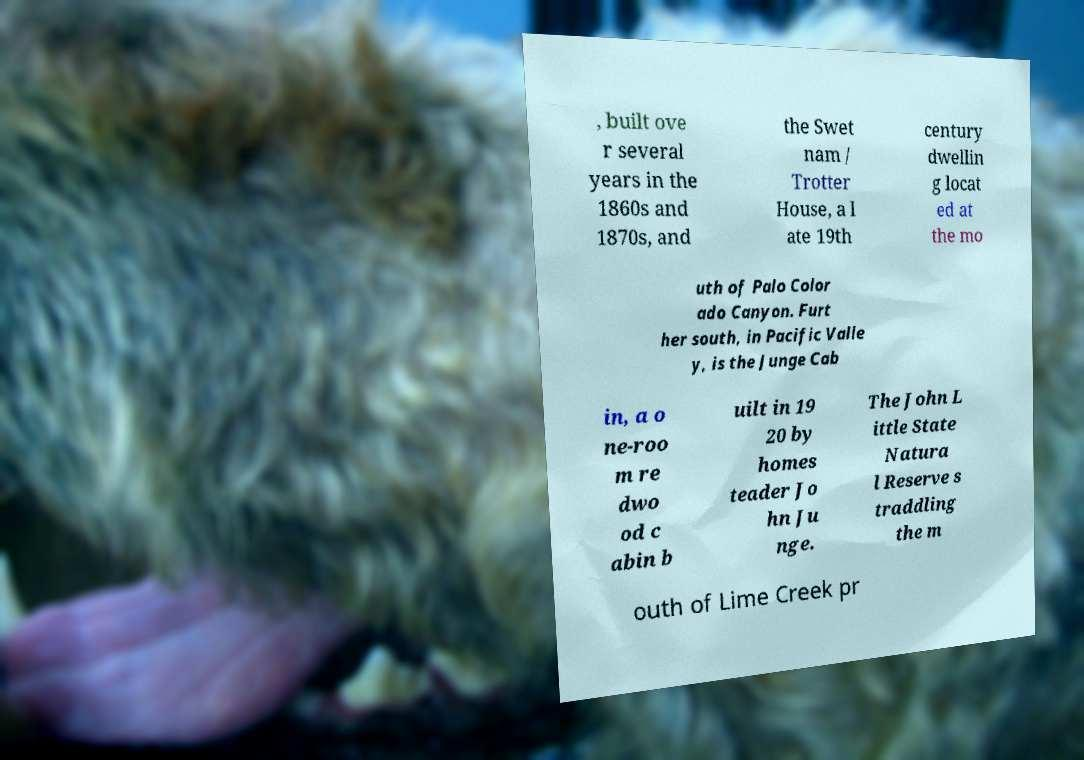Please identify and transcribe the text found in this image. , built ove r several years in the 1860s and 1870s, and the Swet nam / Trotter House, a l ate 19th century dwellin g locat ed at the mo uth of Palo Color ado Canyon. Furt her south, in Pacific Valle y, is the Junge Cab in, a o ne-roo m re dwo od c abin b uilt in 19 20 by homes teader Jo hn Ju nge. The John L ittle State Natura l Reserve s traddling the m outh of Lime Creek pr 